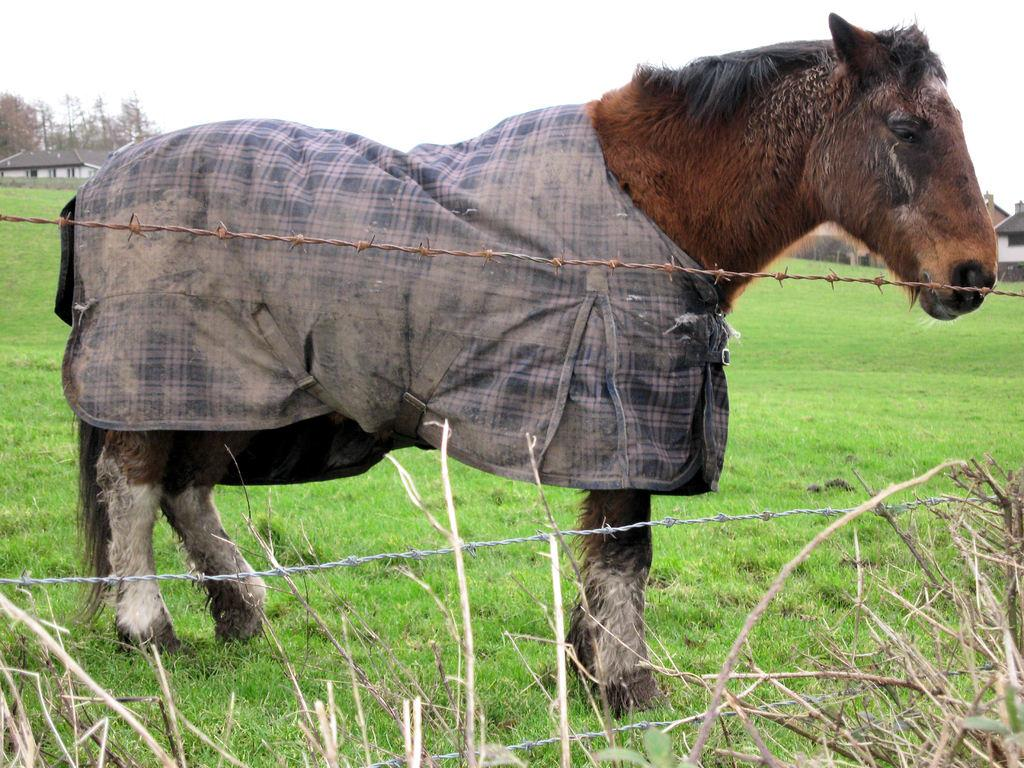What type of animal is in the image? There is a brown horse in the image. What is the color of the grass at the bottom of the image? There is green grass at the bottom of the image. Where is the house located in the image? The house is to the left of the image. What type of suit is the police officer wearing in the image? There are no police officers or suits present in the image. 